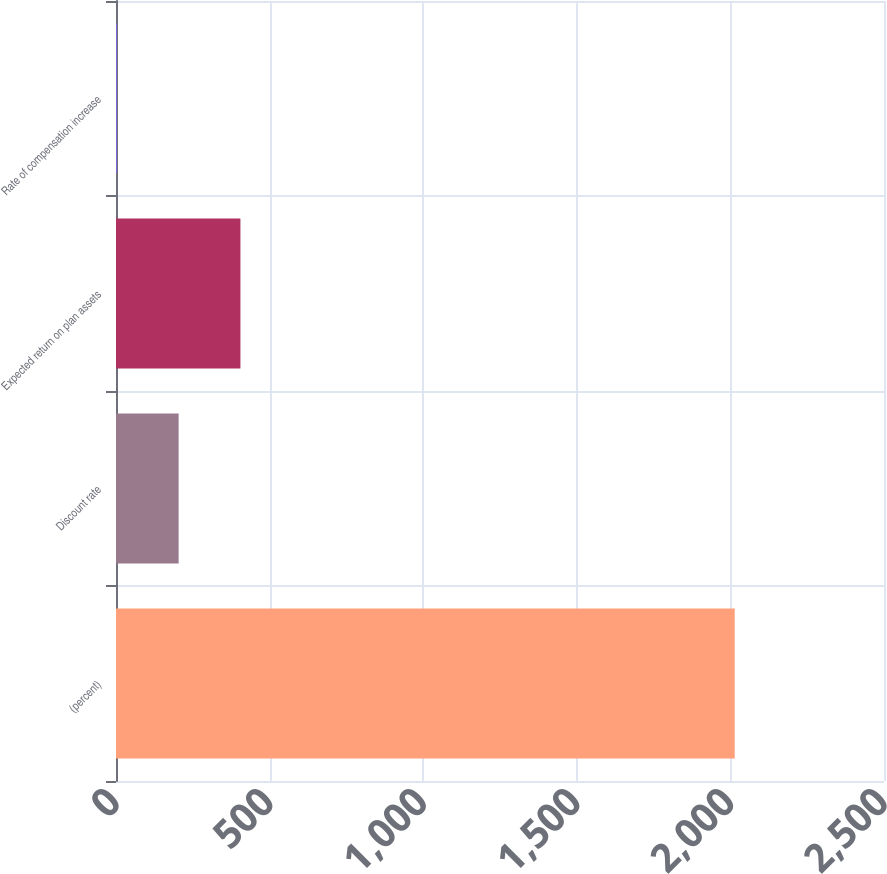Convert chart to OTSL. <chart><loc_0><loc_0><loc_500><loc_500><bar_chart><fcel>(percent)<fcel>Discount rate<fcel>Expected return on plan assets<fcel>Rate of compensation increase<nl><fcel>2014<fcel>203.89<fcel>405.01<fcel>2.77<nl></chart> 